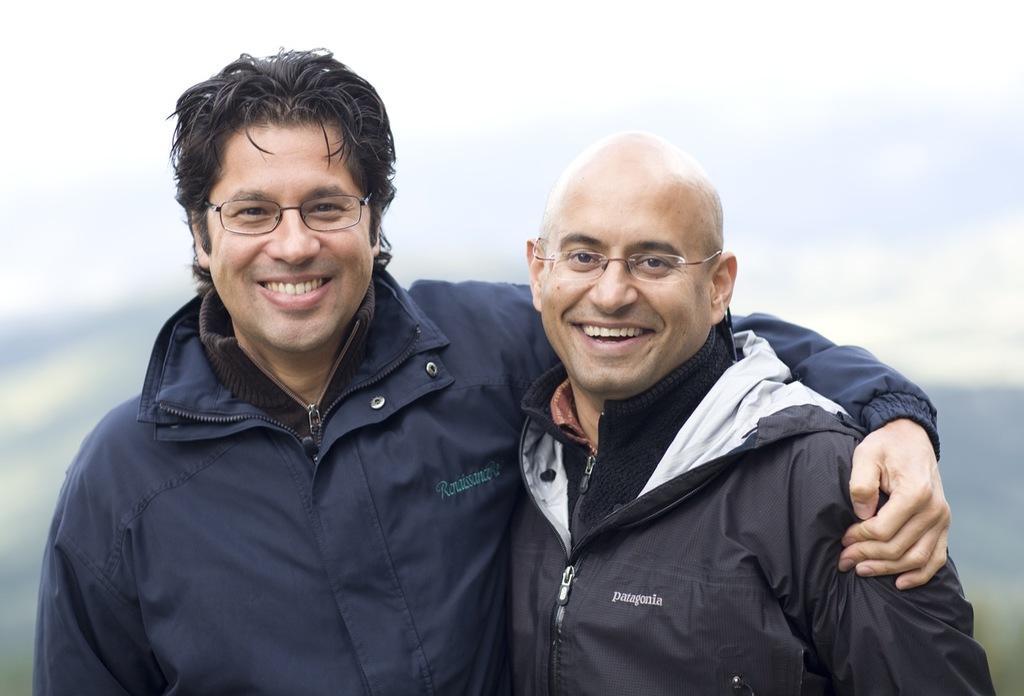Can you describe this image briefly? In this image I can see the person standing and I can see the blurred background. 